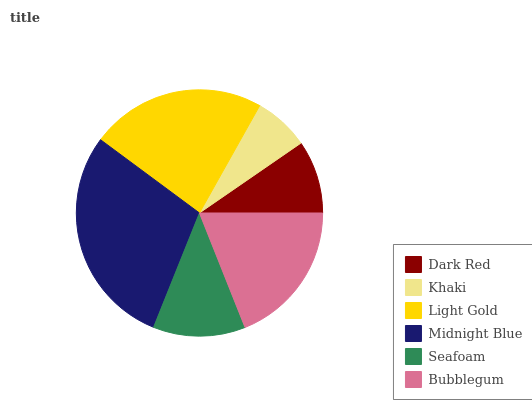Is Khaki the minimum?
Answer yes or no. Yes. Is Midnight Blue the maximum?
Answer yes or no. Yes. Is Light Gold the minimum?
Answer yes or no. No. Is Light Gold the maximum?
Answer yes or no. No. Is Light Gold greater than Khaki?
Answer yes or no. Yes. Is Khaki less than Light Gold?
Answer yes or no. Yes. Is Khaki greater than Light Gold?
Answer yes or no. No. Is Light Gold less than Khaki?
Answer yes or no. No. Is Bubblegum the high median?
Answer yes or no. Yes. Is Seafoam the low median?
Answer yes or no. Yes. Is Dark Red the high median?
Answer yes or no. No. Is Light Gold the low median?
Answer yes or no. No. 